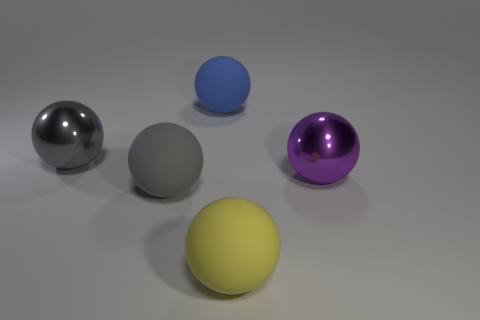Subtract 1 balls. How many balls are left? 4 Subtract all yellow spheres. How many spheres are left? 4 Subtract all purple metallic spheres. How many spheres are left? 4 Subtract all purple spheres. Subtract all green blocks. How many spheres are left? 4 Add 5 big rubber spheres. How many objects exist? 10 Add 5 big cyan shiny balls. How many big cyan shiny balls exist? 5 Subtract 0 gray blocks. How many objects are left? 5 Subtract all green metal cubes. Subtract all blue matte objects. How many objects are left? 4 Add 4 purple metal spheres. How many purple metal spheres are left? 5 